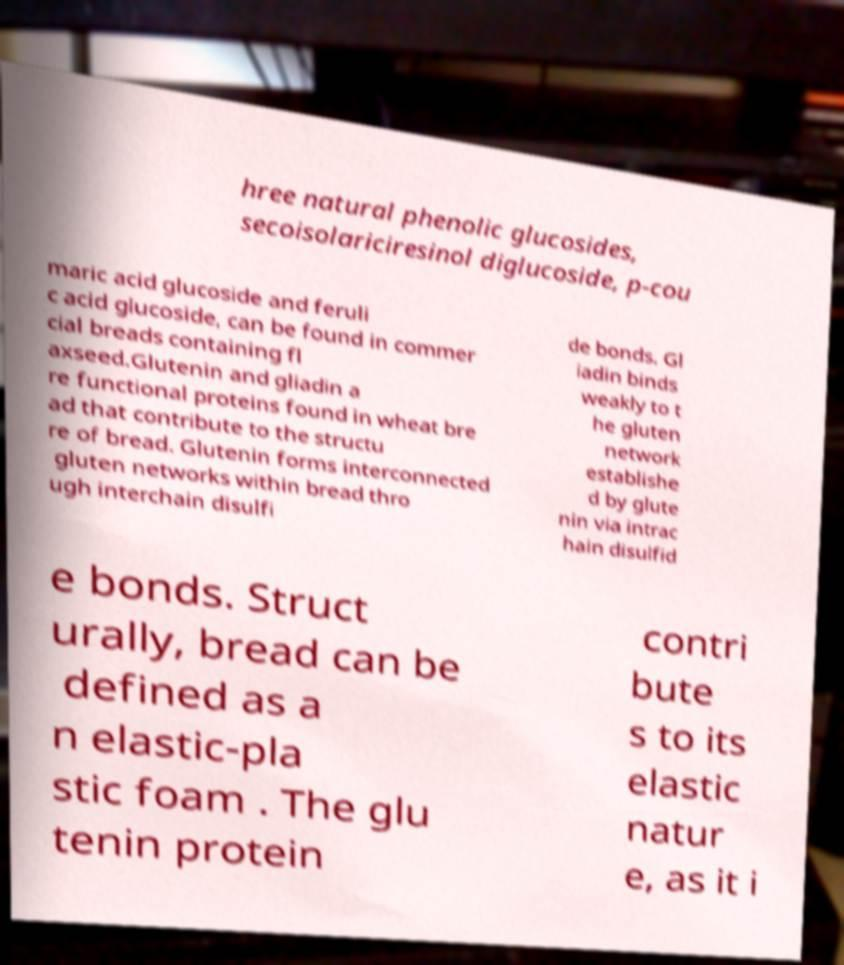What messages or text are displayed in this image? I need them in a readable, typed format. hree natural phenolic glucosides, secoisolariciresinol diglucoside, p-cou maric acid glucoside and feruli c acid glucoside, can be found in commer cial breads containing fl axseed.Glutenin and gliadin a re functional proteins found in wheat bre ad that contribute to the structu re of bread. Glutenin forms interconnected gluten networks within bread thro ugh interchain disulfi de bonds. Gl iadin binds weakly to t he gluten network establishe d by glute nin via intrac hain disulfid e bonds. Struct urally, bread can be defined as a n elastic-pla stic foam . The glu tenin protein contri bute s to its elastic natur e, as it i 